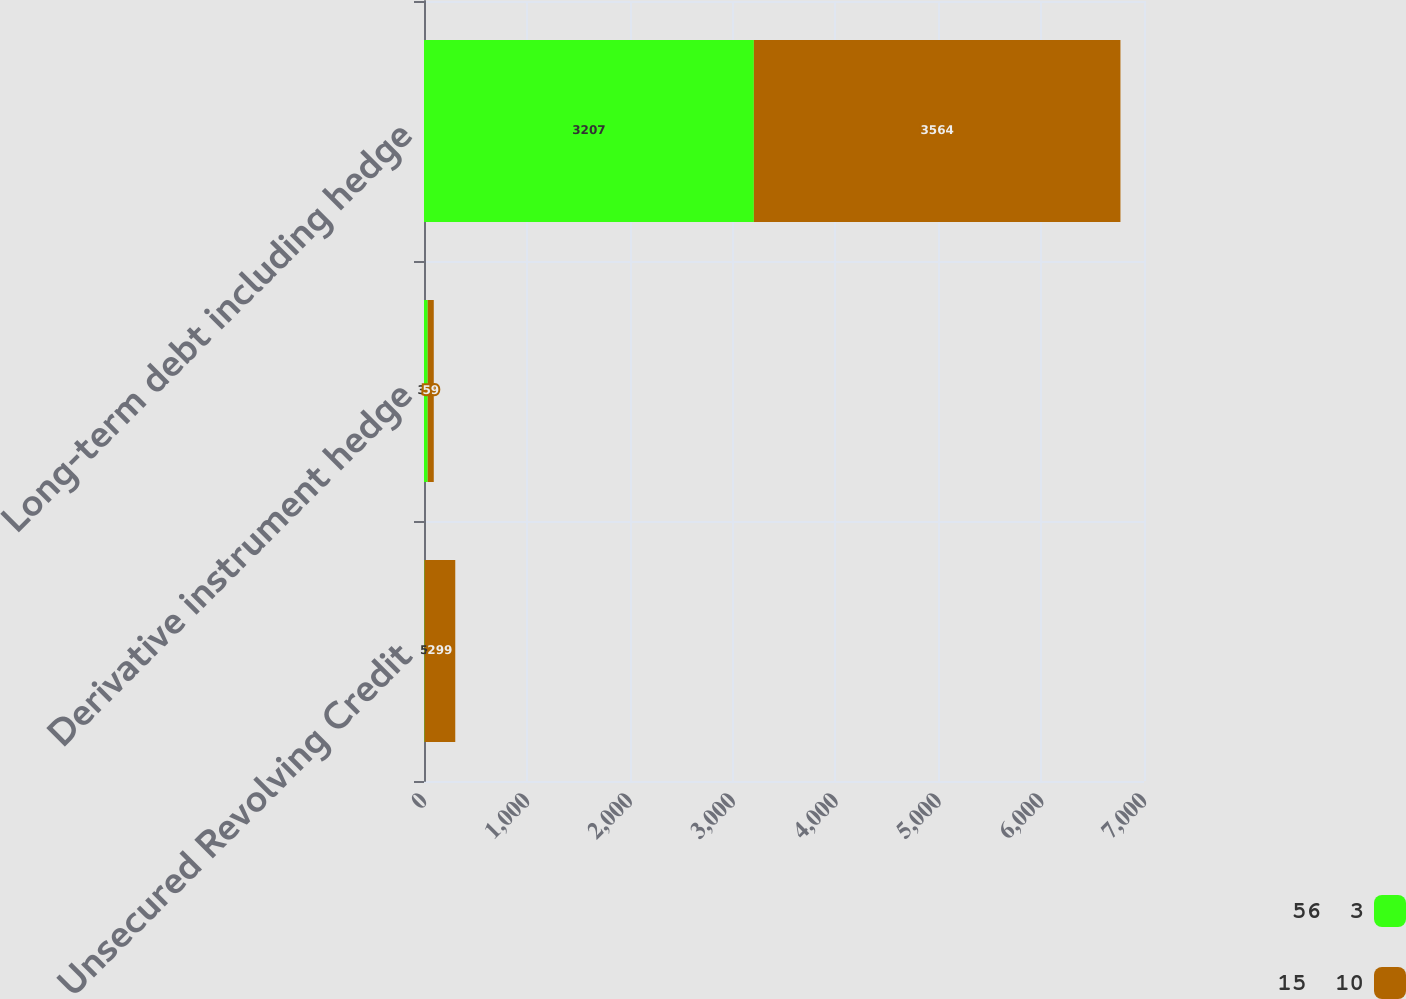Convert chart to OTSL. <chart><loc_0><loc_0><loc_500><loc_500><stacked_bar_chart><ecel><fcel>Unsecured Revolving Credit<fcel>Derivative instrument hedge<fcel>Long-term debt including hedge<nl><fcel>56  3<fcel>5<fcel>36<fcel>3207<nl><fcel>15  10<fcel>299<fcel>59<fcel>3564<nl></chart> 